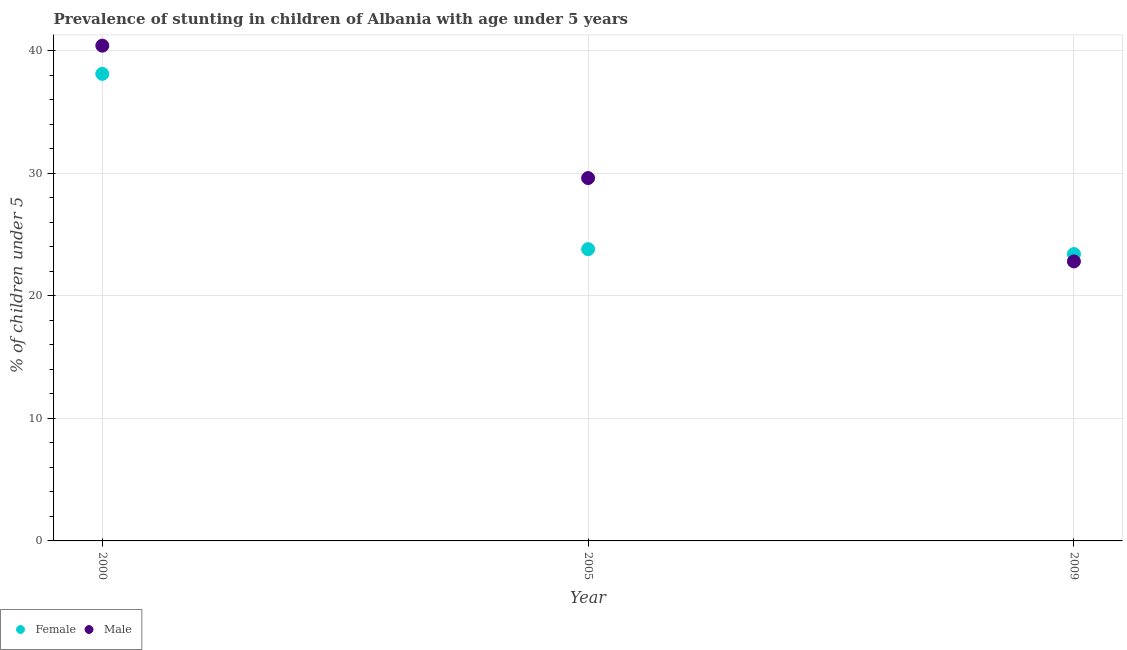How many different coloured dotlines are there?
Give a very brief answer. 2. What is the percentage of stunted male children in 2009?
Provide a succinct answer. 22.8. Across all years, what is the maximum percentage of stunted female children?
Keep it short and to the point. 38.1. Across all years, what is the minimum percentage of stunted female children?
Make the answer very short. 23.4. What is the total percentage of stunted male children in the graph?
Your answer should be compact. 92.8. What is the difference between the percentage of stunted female children in 2000 and that in 2009?
Give a very brief answer. 14.7. What is the difference between the percentage of stunted female children in 2000 and the percentage of stunted male children in 2009?
Keep it short and to the point. 15.3. What is the average percentage of stunted male children per year?
Your answer should be very brief. 30.93. In the year 2000, what is the difference between the percentage of stunted male children and percentage of stunted female children?
Give a very brief answer. 2.3. In how many years, is the percentage of stunted female children greater than 6 %?
Ensure brevity in your answer.  3. What is the ratio of the percentage of stunted male children in 2000 to that in 2005?
Your response must be concise. 1.36. Is the difference between the percentage of stunted female children in 2000 and 2009 greater than the difference between the percentage of stunted male children in 2000 and 2009?
Give a very brief answer. No. What is the difference between the highest and the second highest percentage of stunted female children?
Make the answer very short. 14.3. What is the difference between the highest and the lowest percentage of stunted female children?
Give a very brief answer. 14.7. In how many years, is the percentage of stunted female children greater than the average percentage of stunted female children taken over all years?
Keep it short and to the point. 1. Does the percentage of stunted male children monotonically increase over the years?
Keep it short and to the point. No. Is the percentage of stunted male children strictly greater than the percentage of stunted female children over the years?
Provide a succinct answer. No. What is the difference between two consecutive major ticks on the Y-axis?
Offer a very short reply. 10. Does the graph contain any zero values?
Provide a succinct answer. No. Does the graph contain grids?
Provide a short and direct response. Yes. Where does the legend appear in the graph?
Provide a succinct answer. Bottom left. How many legend labels are there?
Your answer should be compact. 2. What is the title of the graph?
Offer a very short reply. Prevalence of stunting in children of Albania with age under 5 years. What is the label or title of the X-axis?
Make the answer very short. Year. What is the label or title of the Y-axis?
Make the answer very short.  % of children under 5. What is the  % of children under 5 in Female in 2000?
Your answer should be very brief. 38.1. What is the  % of children under 5 of Male in 2000?
Provide a succinct answer. 40.4. What is the  % of children under 5 in Female in 2005?
Keep it short and to the point. 23.8. What is the  % of children under 5 of Male in 2005?
Give a very brief answer. 29.6. What is the  % of children under 5 in Female in 2009?
Ensure brevity in your answer.  23.4. What is the  % of children under 5 in Male in 2009?
Your answer should be compact. 22.8. Across all years, what is the maximum  % of children under 5 in Female?
Provide a short and direct response. 38.1. Across all years, what is the maximum  % of children under 5 of Male?
Your answer should be compact. 40.4. Across all years, what is the minimum  % of children under 5 of Female?
Your response must be concise. 23.4. Across all years, what is the minimum  % of children under 5 in Male?
Your answer should be very brief. 22.8. What is the total  % of children under 5 in Female in the graph?
Provide a succinct answer. 85.3. What is the total  % of children under 5 in Male in the graph?
Offer a terse response. 92.8. What is the difference between the  % of children under 5 in Male in 2000 and that in 2009?
Provide a short and direct response. 17.6. What is the difference between the  % of children under 5 of Female in 2005 and that in 2009?
Your answer should be very brief. 0.4. What is the difference between the  % of children under 5 of Male in 2005 and that in 2009?
Provide a short and direct response. 6.8. What is the difference between the  % of children under 5 of Female in 2000 and the  % of children under 5 of Male in 2005?
Make the answer very short. 8.5. What is the difference between the  % of children under 5 of Female in 2005 and the  % of children under 5 of Male in 2009?
Ensure brevity in your answer.  1. What is the average  % of children under 5 of Female per year?
Your answer should be compact. 28.43. What is the average  % of children under 5 of Male per year?
Offer a terse response. 30.93. In the year 2000, what is the difference between the  % of children under 5 of Female and  % of children under 5 of Male?
Make the answer very short. -2.3. In the year 2009, what is the difference between the  % of children under 5 of Female and  % of children under 5 of Male?
Keep it short and to the point. 0.6. What is the ratio of the  % of children under 5 of Female in 2000 to that in 2005?
Provide a short and direct response. 1.6. What is the ratio of the  % of children under 5 of Male in 2000 to that in 2005?
Offer a very short reply. 1.36. What is the ratio of the  % of children under 5 of Female in 2000 to that in 2009?
Your response must be concise. 1.63. What is the ratio of the  % of children under 5 of Male in 2000 to that in 2009?
Make the answer very short. 1.77. What is the ratio of the  % of children under 5 in Female in 2005 to that in 2009?
Offer a terse response. 1.02. What is the ratio of the  % of children under 5 in Male in 2005 to that in 2009?
Offer a very short reply. 1.3. What is the difference between the highest and the second highest  % of children under 5 of Female?
Offer a very short reply. 14.3. What is the difference between the highest and the second highest  % of children under 5 in Male?
Ensure brevity in your answer.  10.8. What is the difference between the highest and the lowest  % of children under 5 in Male?
Give a very brief answer. 17.6. 